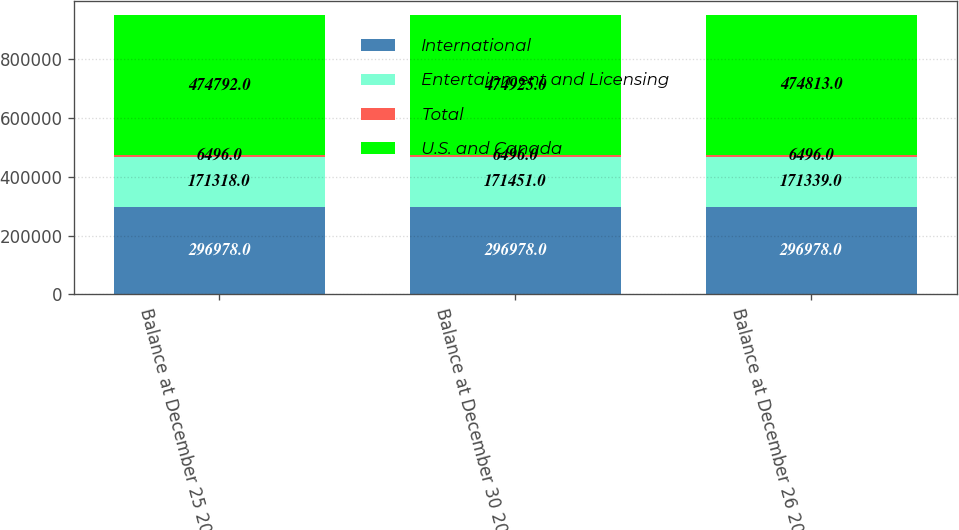Convert chart to OTSL. <chart><loc_0><loc_0><loc_500><loc_500><stacked_bar_chart><ecel><fcel>Balance at December 25 2011<fcel>Balance at December 30 2012<fcel>Balance at December 26 2010<nl><fcel>International<fcel>296978<fcel>296978<fcel>296978<nl><fcel>Entertainment and Licensing<fcel>171318<fcel>171451<fcel>171339<nl><fcel>Total<fcel>6496<fcel>6496<fcel>6496<nl><fcel>U.S. and Canada<fcel>474792<fcel>474925<fcel>474813<nl></chart> 